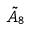<formula> <loc_0><loc_0><loc_500><loc_500>\tilde { A } _ { 8 }</formula> 